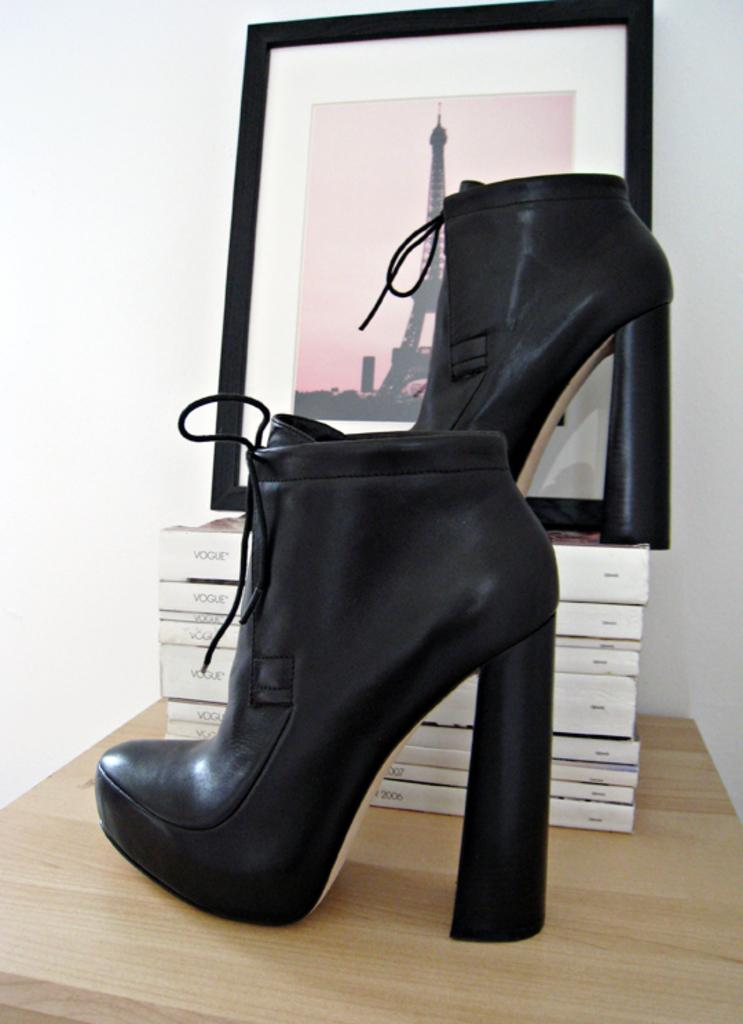What type of shoe is on the table in the image? There is a black heel on the table in the image. What can be seen behind the heel? There are books behind the heel. What is on top of the books? There is a frame on the books. What is beside the frame? There is another heel beside the frame. Can you see any hills or wilderness in the image? No, there are no hills or wilderness present in the image; it features a table with various objects on it. 